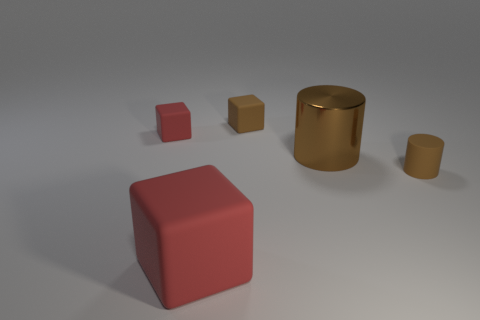Subtract all red blocks. How many were subtracted if there are1red blocks left? 1 Subtract all red blocks. How many blocks are left? 1 Subtract all blocks. How many objects are left? 2 Subtract all green blocks. Subtract all cyan cylinders. How many blocks are left? 3 Subtract all cyan cubes. How many yellow cylinders are left? 0 Subtract all brown things. Subtract all brown cylinders. How many objects are left? 0 Add 1 tiny brown cylinders. How many tiny brown cylinders are left? 2 Add 1 tiny purple balls. How many tiny purple balls exist? 1 Add 5 tiny brown matte cylinders. How many objects exist? 10 Subtract all small red rubber blocks. How many blocks are left? 2 